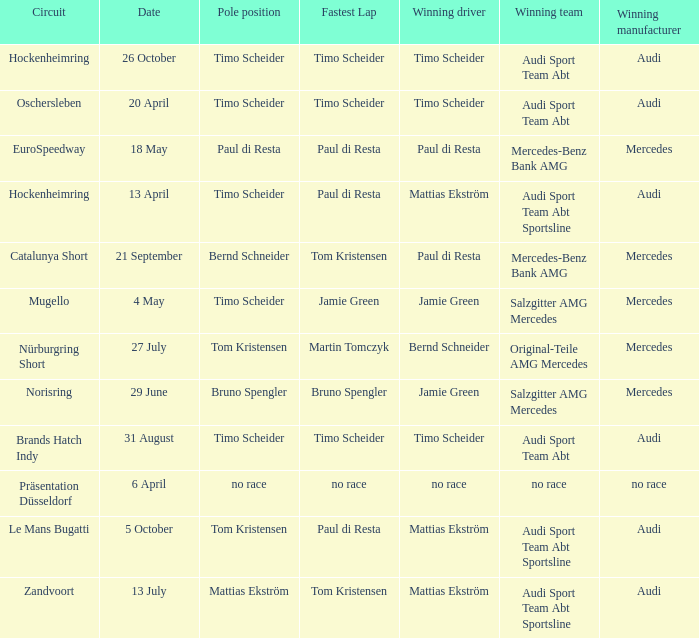Who is the winning driver of the race with no race as the winning manufacturer? No race. 